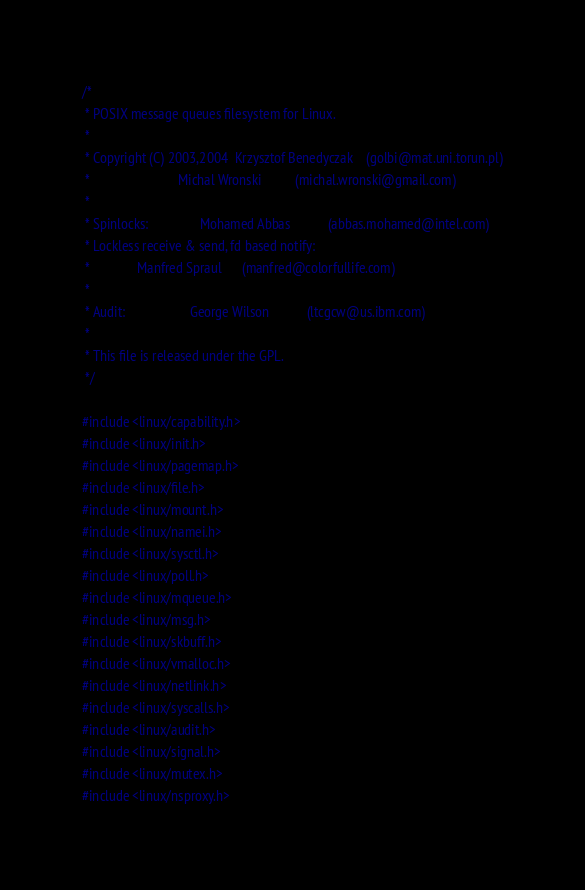<code> <loc_0><loc_0><loc_500><loc_500><_C_>/*
 * POSIX message queues filesystem for Linux.
 *
 * Copyright (C) 2003,2004  Krzysztof Benedyczak    (golbi@mat.uni.torun.pl)
 *                          Michal Wronski          (michal.wronski@gmail.com)
 *
 * Spinlocks:               Mohamed Abbas           (abbas.mohamed@intel.com)
 * Lockless receive & send, fd based notify:
 *			    Manfred Spraul	    (manfred@colorfullife.com)
 *
 * Audit:                   George Wilson           (ltcgcw@us.ibm.com)
 *
 * This file is released under the GPL.
 */

#include <linux/capability.h>
#include <linux/init.h>
#include <linux/pagemap.h>
#include <linux/file.h>
#include <linux/mount.h>
#include <linux/namei.h>
#include <linux/sysctl.h>
#include <linux/poll.h>
#include <linux/mqueue.h>
#include <linux/msg.h>
#include <linux/skbuff.h>
#include <linux/vmalloc.h>
#include <linux/netlink.h>
#include <linux/syscalls.h>
#include <linux/audit.h>
#include <linux/signal.h>
#include <linux/mutex.h>
#include <linux/nsproxy.h></code> 